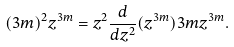<formula> <loc_0><loc_0><loc_500><loc_500>( 3 m ) ^ { 2 } z ^ { 3 m } = z ^ { 2 } \frac { d } { d z ^ { 2 } } ( z ^ { 3 m } ) 3 m z ^ { 3 m } .</formula> 